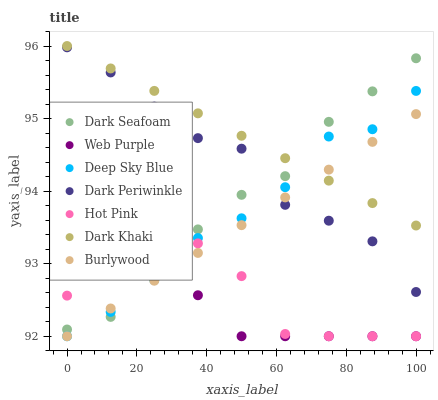Does Web Purple have the minimum area under the curve?
Answer yes or no. Yes. Does Dark Khaki have the maximum area under the curve?
Answer yes or no. Yes. Does Hot Pink have the minimum area under the curve?
Answer yes or no. No. Does Hot Pink have the maximum area under the curve?
Answer yes or no. No. Is Dark Khaki the smoothest?
Answer yes or no. Yes. Is Hot Pink the roughest?
Answer yes or no. Yes. Is Web Purple the smoothest?
Answer yes or no. No. Is Web Purple the roughest?
Answer yes or no. No. Does Burlywood have the lowest value?
Answer yes or no. Yes. Does Dark Khaki have the lowest value?
Answer yes or no. No. Does Dark Khaki have the highest value?
Answer yes or no. Yes. Does Hot Pink have the highest value?
Answer yes or no. No. Is Hot Pink less than Dark Khaki?
Answer yes or no. Yes. Is Dark Periwinkle greater than Hot Pink?
Answer yes or no. Yes. Does Dark Seafoam intersect Dark Khaki?
Answer yes or no. Yes. Is Dark Seafoam less than Dark Khaki?
Answer yes or no. No. Is Dark Seafoam greater than Dark Khaki?
Answer yes or no. No. Does Hot Pink intersect Dark Khaki?
Answer yes or no. No. 